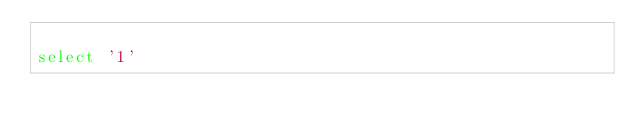<code> <loc_0><loc_0><loc_500><loc_500><_SQL_>
select '1'

</code> 